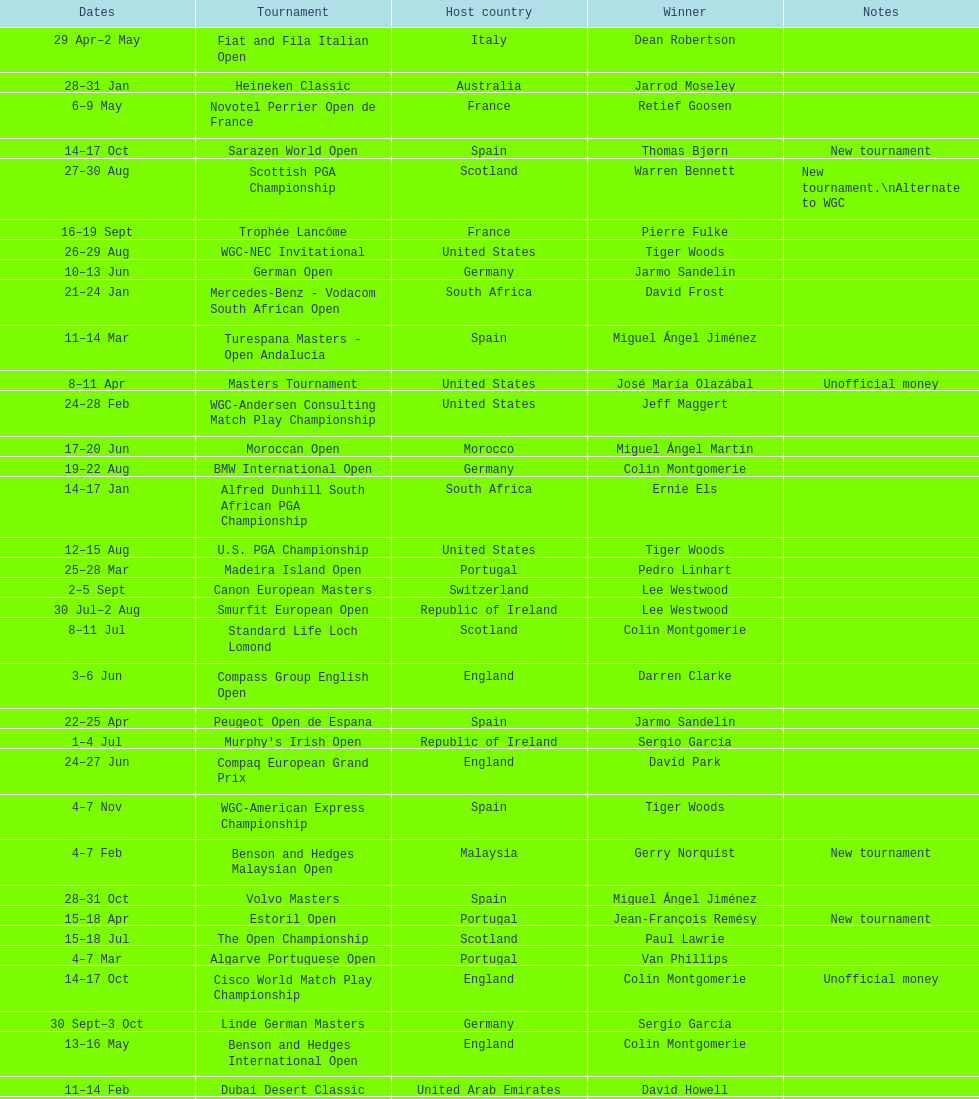Which winner won more tournaments, jeff maggert or tiger woods? Tiger Woods. 